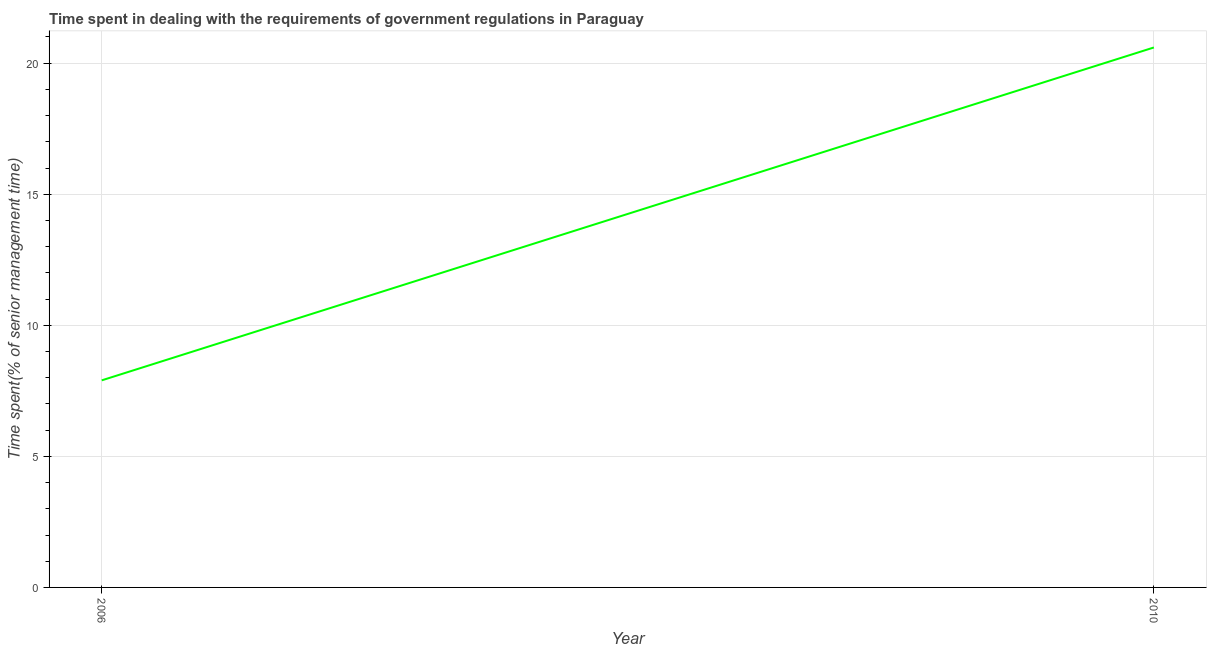What is the time spent in dealing with government regulations in 2010?
Give a very brief answer. 20.6. Across all years, what is the maximum time spent in dealing with government regulations?
Your answer should be very brief. 20.6. In which year was the time spent in dealing with government regulations minimum?
Your answer should be compact. 2006. What is the sum of the time spent in dealing with government regulations?
Ensure brevity in your answer.  28.5. What is the difference between the time spent in dealing with government regulations in 2006 and 2010?
Give a very brief answer. -12.7. What is the average time spent in dealing with government regulations per year?
Your answer should be compact. 14.25. What is the median time spent in dealing with government regulations?
Offer a terse response. 14.25. Do a majority of the years between 2010 and 2006 (inclusive) have time spent in dealing with government regulations greater than 16 %?
Keep it short and to the point. No. What is the ratio of the time spent in dealing with government regulations in 2006 to that in 2010?
Provide a short and direct response. 0.38. Is the time spent in dealing with government regulations in 2006 less than that in 2010?
Make the answer very short. Yes. In how many years, is the time spent in dealing with government regulations greater than the average time spent in dealing with government regulations taken over all years?
Provide a succinct answer. 1. How many years are there in the graph?
Make the answer very short. 2. Does the graph contain any zero values?
Provide a short and direct response. No. Does the graph contain grids?
Offer a very short reply. Yes. What is the title of the graph?
Provide a short and direct response. Time spent in dealing with the requirements of government regulations in Paraguay. What is the label or title of the Y-axis?
Provide a succinct answer. Time spent(% of senior management time). What is the Time spent(% of senior management time) of 2006?
Your answer should be compact. 7.9. What is the Time spent(% of senior management time) in 2010?
Ensure brevity in your answer.  20.6. What is the ratio of the Time spent(% of senior management time) in 2006 to that in 2010?
Your answer should be very brief. 0.38. 